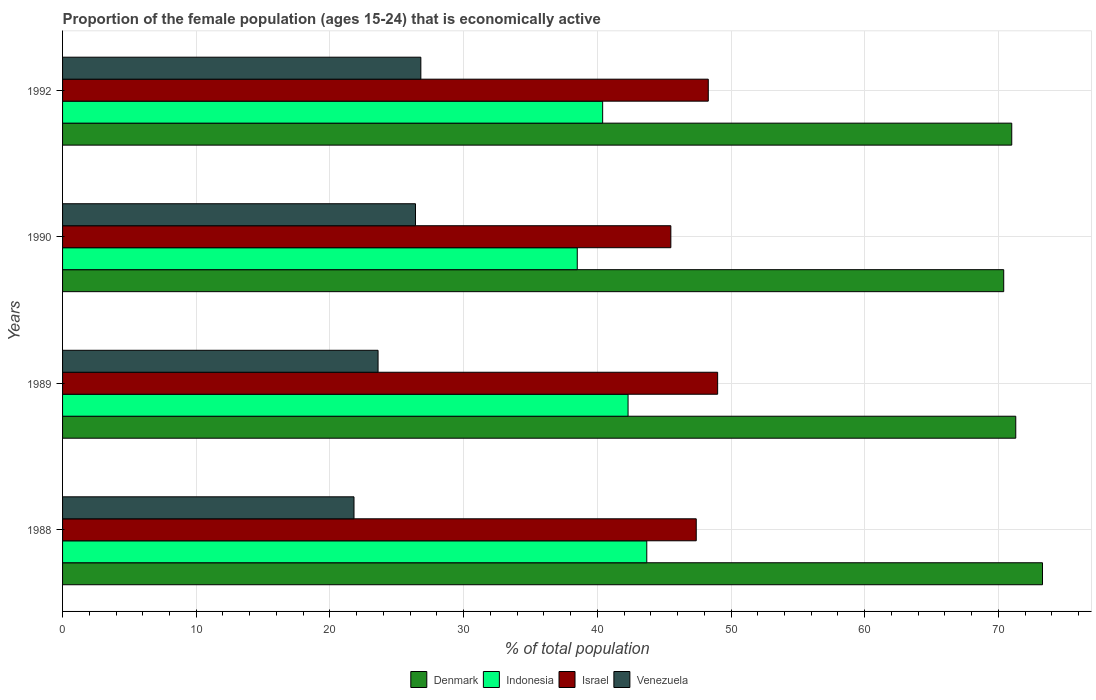How many different coloured bars are there?
Your response must be concise. 4. How many groups of bars are there?
Your answer should be very brief. 4. Are the number of bars on each tick of the Y-axis equal?
Make the answer very short. Yes. How many bars are there on the 3rd tick from the bottom?
Ensure brevity in your answer.  4. What is the label of the 2nd group of bars from the top?
Your answer should be compact. 1990. What is the proportion of the female population that is economically active in Denmark in 1988?
Give a very brief answer. 73.3. Across all years, what is the maximum proportion of the female population that is economically active in Denmark?
Ensure brevity in your answer.  73.3. Across all years, what is the minimum proportion of the female population that is economically active in Denmark?
Offer a very short reply. 70.4. In which year was the proportion of the female population that is economically active in Venezuela maximum?
Offer a very short reply. 1992. In which year was the proportion of the female population that is economically active in Israel minimum?
Provide a succinct answer. 1990. What is the total proportion of the female population that is economically active in Israel in the graph?
Make the answer very short. 190.2. What is the difference between the proportion of the female population that is economically active in Denmark in 1988 and that in 1989?
Ensure brevity in your answer.  2. What is the difference between the proportion of the female population that is economically active in Indonesia in 1990 and the proportion of the female population that is economically active in Israel in 1988?
Make the answer very short. -8.9. What is the average proportion of the female population that is economically active in Denmark per year?
Give a very brief answer. 71.5. In the year 1990, what is the difference between the proportion of the female population that is economically active in Israel and proportion of the female population that is economically active in Venezuela?
Give a very brief answer. 19.1. In how many years, is the proportion of the female population that is economically active in Israel greater than 62 %?
Provide a succinct answer. 0. What is the ratio of the proportion of the female population that is economically active in Indonesia in 1989 to that in 1992?
Provide a short and direct response. 1.05. Is the proportion of the female population that is economically active in Israel in 1989 less than that in 1992?
Ensure brevity in your answer.  No. Is the difference between the proportion of the female population that is economically active in Israel in 1988 and 1989 greater than the difference between the proportion of the female population that is economically active in Venezuela in 1988 and 1989?
Provide a short and direct response. Yes. What is the difference between the highest and the second highest proportion of the female population that is economically active in Israel?
Ensure brevity in your answer.  0.7. What is the difference between the highest and the lowest proportion of the female population that is economically active in Indonesia?
Your answer should be very brief. 5.2. What does the 2nd bar from the bottom in 1990 represents?
Make the answer very short. Indonesia. Is it the case that in every year, the sum of the proportion of the female population that is economically active in Denmark and proportion of the female population that is economically active in Indonesia is greater than the proportion of the female population that is economically active in Israel?
Your response must be concise. Yes. Are all the bars in the graph horizontal?
Provide a succinct answer. Yes. What is the difference between two consecutive major ticks on the X-axis?
Offer a terse response. 10. Are the values on the major ticks of X-axis written in scientific E-notation?
Your answer should be compact. No. Does the graph contain any zero values?
Ensure brevity in your answer.  No. What is the title of the graph?
Offer a terse response. Proportion of the female population (ages 15-24) that is economically active. What is the label or title of the X-axis?
Provide a succinct answer. % of total population. What is the label or title of the Y-axis?
Keep it short and to the point. Years. What is the % of total population in Denmark in 1988?
Provide a succinct answer. 73.3. What is the % of total population of Indonesia in 1988?
Give a very brief answer. 43.7. What is the % of total population of Israel in 1988?
Give a very brief answer. 47.4. What is the % of total population in Venezuela in 1988?
Give a very brief answer. 21.8. What is the % of total population in Denmark in 1989?
Your answer should be very brief. 71.3. What is the % of total population in Indonesia in 1989?
Provide a short and direct response. 42.3. What is the % of total population in Venezuela in 1989?
Provide a succinct answer. 23.6. What is the % of total population in Denmark in 1990?
Offer a terse response. 70.4. What is the % of total population of Indonesia in 1990?
Offer a very short reply. 38.5. What is the % of total population in Israel in 1990?
Ensure brevity in your answer.  45.5. What is the % of total population in Venezuela in 1990?
Give a very brief answer. 26.4. What is the % of total population in Denmark in 1992?
Offer a very short reply. 71. What is the % of total population in Indonesia in 1992?
Ensure brevity in your answer.  40.4. What is the % of total population in Israel in 1992?
Provide a short and direct response. 48.3. What is the % of total population of Venezuela in 1992?
Your answer should be very brief. 26.8. Across all years, what is the maximum % of total population in Denmark?
Your answer should be very brief. 73.3. Across all years, what is the maximum % of total population of Indonesia?
Ensure brevity in your answer.  43.7. Across all years, what is the maximum % of total population in Venezuela?
Provide a short and direct response. 26.8. Across all years, what is the minimum % of total population in Denmark?
Ensure brevity in your answer.  70.4. Across all years, what is the minimum % of total population of Indonesia?
Ensure brevity in your answer.  38.5. Across all years, what is the minimum % of total population in Israel?
Keep it short and to the point. 45.5. Across all years, what is the minimum % of total population in Venezuela?
Make the answer very short. 21.8. What is the total % of total population of Denmark in the graph?
Your response must be concise. 286. What is the total % of total population of Indonesia in the graph?
Provide a succinct answer. 164.9. What is the total % of total population of Israel in the graph?
Provide a short and direct response. 190.2. What is the total % of total population of Venezuela in the graph?
Your answer should be very brief. 98.6. What is the difference between the % of total population of Indonesia in 1988 and that in 1990?
Ensure brevity in your answer.  5.2. What is the difference between the % of total population of Venezuela in 1988 and that in 1990?
Offer a terse response. -4.6. What is the difference between the % of total population in Denmark in 1988 and that in 1992?
Provide a short and direct response. 2.3. What is the difference between the % of total population in Israel in 1988 and that in 1992?
Offer a very short reply. -0.9. What is the difference between the % of total population of Denmark in 1989 and that in 1990?
Your answer should be very brief. 0.9. What is the difference between the % of total population in Indonesia in 1989 and that in 1990?
Give a very brief answer. 3.8. What is the difference between the % of total population in Israel in 1989 and that in 1990?
Keep it short and to the point. 3.5. What is the difference between the % of total population of Denmark in 1989 and that in 1992?
Your answer should be very brief. 0.3. What is the difference between the % of total population in Israel in 1990 and that in 1992?
Your answer should be compact. -2.8. What is the difference between the % of total population in Venezuela in 1990 and that in 1992?
Give a very brief answer. -0.4. What is the difference between the % of total population of Denmark in 1988 and the % of total population of Israel in 1989?
Your answer should be compact. 24.3. What is the difference between the % of total population of Denmark in 1988 and the % of total population of Venezuela in 1989?
Provide a succinct answer. 49.7. What is the difference between the % of total population in Indonesia in 1988 and the % of total population in Israel in 1989?
Offer a very short reply. -5.3. What is the difference between the % of total population of Indonesia in 1988 and the % of total population of Venezuela in 1989?
Offer a very short reply. 20.1. What is the difference between the % of total population in Israel in 1988 and the % of total population in Venezuela in 1989?
Your response must be concise. 23.8. What is the difference between the % of total population in Denmark in 1988 and the % of total population in Indonesia in 1990?
Your answer should be very brief. 34.8. What is the difference between the % of total population in Denmark in 1988 and the % of total population in Israel in 1990?
Offer a very short reply. 27.8. What is the difference between the % of total population of Denmark in 1988 and the % of total population of Venezuela in 1990?
Your answer should be compact. 46.9. What is the difference between the % of total population in Indonesia in 1988 and the % of total population in Israel in 1990?
Make the answer very short. -1.8. What is the difference between the % of total population of Israel in 1988 and the % of total population of Venezuela in 1990?
Your response must be concise. 21. What is the difference between the % of total population of Denmark in 1988 and the % of total population of Indonesia in 1992?
Keep it short and to the point. 32.9. What is the difference between the % of total population in Denmark in 1988 and the % of total population in Venezuela in 1992?
Offer a terse response. 46.5. What is the difference between the % of total population in Indonesia in 1988 and the % of total population in Israel in 1992?
Ensure brevity in your answer.  -4.6. What is the difference between the % of total population in Israel in 1988 and the % of total population in Venezuela in 1992?
Provide a succinct answer. 20.6. What is the difference between the % of total population in Denmark in 1989 and the % of total population in Indonesia in 1990?
Keep it short and to the point. 32.8. What is the difference between the % of total population in Denmark in 1989 and the % of total population in Israel in 1990?
Provide a succinct answer. 25.8. What is the difference between the % of total population of Denmark in 1989 and the % of total population of Venezuela in 1990?
Ensure brevity in your answer.  44.9. What is the difference between the % of total population in Indonesia in 1989 and the % of total population in Israel in 1990?
Give a very brief answer. -3.2. What is the difference between the % of total population in Israel in 1989 and the % of total population in Venezuela in 1990?
Your answer should be very brief. 22.6. What is the difference between the % of total population in Denmark in 1989 and the % of total population in Indonesia in 1992?
Your response must be concise. 30.9. What is the difference between the % of total population in Denmark in 1989 and the % of total population in Venezuela in 1992?
Your answer should be very brief. 44.5. What is the difference between the % of total population of Indonesia in 1989 and the % of total population of Israel in 1992?
Offer a terse response. -6. What is the difference between the % of total population in Indonesia in 1989 and the % of total population in Venezuela in 1992?
Your answer should be very brief. 15.5. What is the difference between the % of total population in Israel in 1989 and the % of total population in Venezuela in 1992?
Provide a short and direct response. 22.2. What is the difference between the % of total population of Denmark in 1990 and the % of total population of Israel in 1992?
Make the answer very short. 22.1. What is the difference between the % of total population of Denmark in 1990 and the % of total population of Venezuela in 1992?
Keep it short and to the point. 43.6. What is the difference between the % of total population of Indonesia in 1990 and the % of total population of Israel in 1992?
Your response must be concise. -9.8. What is the difference between the % of total population in Indonesia in 1990 and the % of total population in Venezuela in 1992?
Offer a very short reply. 11.7. What is the average % of total population of Denmark per year?
Your response must be concise. 71.5. What is the average % of total population in Indonesia per year?
Make the answer very short. 41.23. What is the average % of total population of Israel per year?
Offer a terse response. 47.55. What is the average % of total population in Venezuela per year?
Offer a terse response. 24.65. In the year 1988, what is the difference between the % of total population in Denmark and % of total population in Indonesia?
Offer a very short reply. 29.6. In the year 1988, what is the difference between the % of total population in Denmark and % of total population in Israel?
Offer a terse response. 25.9. In the year 1988, what is the difference between the % of total population of Denmark and % of total population of Venezuela?
Make the answer very short. 51.5. In the year 1988, what is the difference between the % of total population in Indonesia and % of total population in Israel?
Your answer should be very brief. -3.7. In the year 1988, what is the difference between the % of total population of Indonesia and % of total population of Venezuela?
Make the answer very short. 21.9. In the year 1988, what is the difference between the % of total population in Israel and % of total population in Venezuela?
Offer a terse response. 25.6. In the year 1989, what is the difference between the % of total population in Denmark and % of total population in Indonesia?
Your answer should be compact. 29. In the year 1989, what is the difference between the % of total population of Denmark and % of total population of Israel?
Your answer should be very brief. 22.3. In the year 1989, what is the difference between the % of total population in Denmark and % of total population in Venezuela?
Ensure brevity in your answer.  47.7. In the year 1989, what is the difference between the % of total population in Indonesia and % of total population in Israel?
Your response must be concise. -6.7. In the year 1989, what is the difference between the % of total population of Indonesia and % of total population of Venezuela?
Offer a very short reply. 18.7. In the year 1989, what is the difference between the % of total population of Israel and % of total population of Venezuela?
Make the answer very short. 25.4. In the year 1990, what is the difference between the % of total population of Denmark and % of total population of Indonesia?
Keep it short and to the point. 31.9. In the year 1990, what is the difference between the % of total population of Denmark and % of total population of Israel?
Give a very brief answer. 24.9. In the year 1990, what is the difference between the % of total population of Denmark and % of total population of Venezuela?
Provide a short and direct response. 44. In the year 1992, what is the difference between the % of total population of Denmark and % of total population of Indonesia?
Your answer should be compact. 30.6. In the year 1992, what is the difference between the % of total population in Denmark and % of total population in Israel?
Provide a succinct answer. 22.7. In the year 1992, what is the difference between the % of total population in Denmark and % of total population in Venezuela?
Ensure brevity in your answer.  44.2. In the year 1992, what is the difference between the % of total population of Indonesia and % of total population of Israel?
Offer a very short reply. -7.9. In the year 1992, what is the difference between the % of total population of Israel and % of total population of Venezuela?
Your answer should be very brief. 21.5. What is the ratio of the % of total population in Denmark in 1988 to that in 1989?
Your answer should be very brief. 1.03. What is the ratio of the % of total population in Indonesia in 1988 to that in 1989?
Keep it short and to the point. 1.03. What is the ratio of the % of total population in Israel in 1988 to that in 1989?
Make the answer very short. 0.97. What is the ratio of the % of total population in Venezuela in 1988 to that in 1989?
Your answer should be compact. 0.92. What is the ratio of the % of total population in Denmark in 1988 to that in 1990?
Provide a short and direct response. 1.04. What is the ratio of the % of total population of Indonesia in 1988 to that in 1990?
Ensure brevity in your answer.  1.14. What is the ratio of the % of total population in Israel in 1988 to that in 1990?
Offer a terse response. 1.04. What is the ratio of the % of total population of Venezuela in 1988 to that in 1990?
Keep it short and to the point. 0.83. What is the ratio of the % of total population of Denmark in 1988 to that in 1992?
Provide a succinct answer. 1.03. What is the ratio of the % of total population of Indonesia in 1988 to that in 1992?
Your answer should be very brief. 1.08. What is the ratio of the % of total population in Israel in 1988 to that in 1992?
Your response must be concise. 0.98. What is the ratio of the % of total population in Venezuela in 1988 to that in 1992?
Give a very brief answer. 0.81. What is the ratio of the % of total population of Denmark in 1989 to that in 1990?
Offer a very short reply. 1.01. What is the ratio of the % of total population of Indonesia in 1989 to that in 1990?
Give a very brief answer. 1.1. What is the ratio of the % of total population in Venezuela in 1989 to that in 1990?
Provide a short and direct response. 0.89. What is the ratio of the % of total population in Indonesia in 1989 to that in 1992?
Offer a terse response. 1.05. What is the ratio of the % of total population in Israel in 1989 to that in 1992?
Offer a terse response. 1.01. What is the ratio of the % of total population of Venezuela in 1989 to that in 1992?
Give a very brief answer. 0.88. What is the ratio of the % of total population in Denmark in 1990 to that in 1992?
Your answer should be compact. 0.99. What is the ratio of the % of total population of Indonesia in 1990 to that in 1992?
Make the answer very short. 0.95. What is the ratio of the % of total population of Israel in 1990 to that in 1992?
Ensure brevity in your answer.  0.94. What is the ratio of the % of total population of Venezuela in 1990 to that in 1992?
Provide a succinct answer. 0.99. What is the difference between the highest and the second highest % of total population of Denmark?
Give a very brief answer. 2. What is the difference between the highest and the second highest % of total population in Indonesia?
Make the answer very short. 1.4. What is the difference between the highest and the second highest % of total population of Israel?
Provide a succinct answer. 0.7. What is the difference between the highest and the lowest % of total population of Israel?
Offer a terse response. 3.5. 